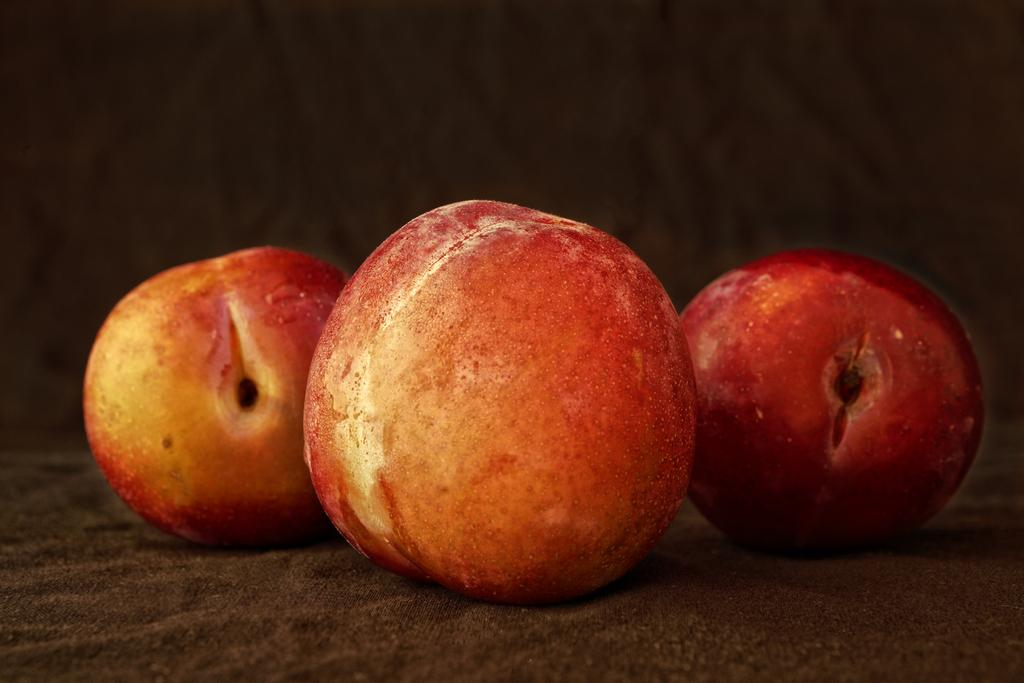How many apples are visible in the image? There are three apples in the image. What color are the apples in the image? The apples are red in color. What type of boundary can be seen in the image? There is no boundary present in the image; it only features three red apples. 